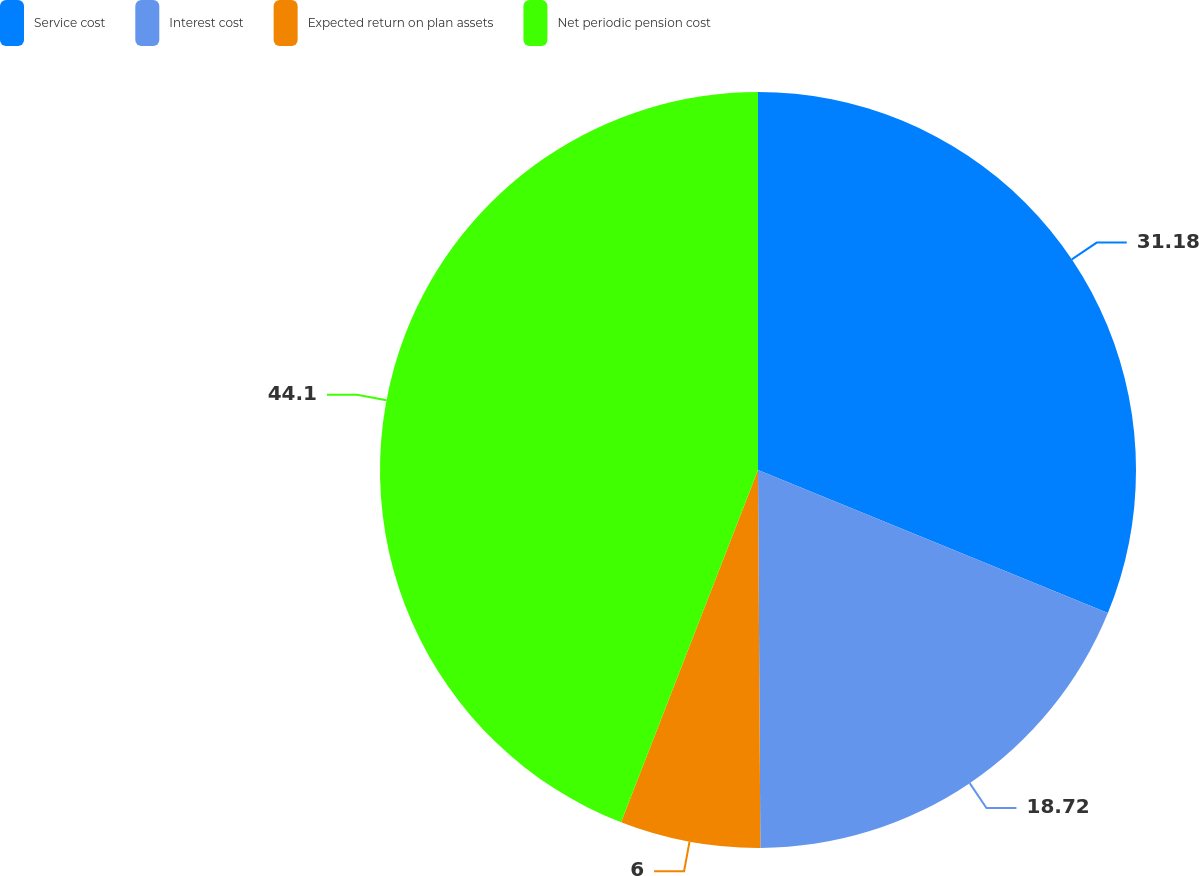Convert chart to OTSL. <chart><loc_0><loc_0><loc_500><loc_500><pie_chart><fcel>Service cost<fcel>Interest cost<fcel>Expected return on plan assets<fcel>Net periodic pension cost<nl><fcel>31.18%<fcel>18.72%<fcel>6.0%<fcel>44.1%<nl></chart> 